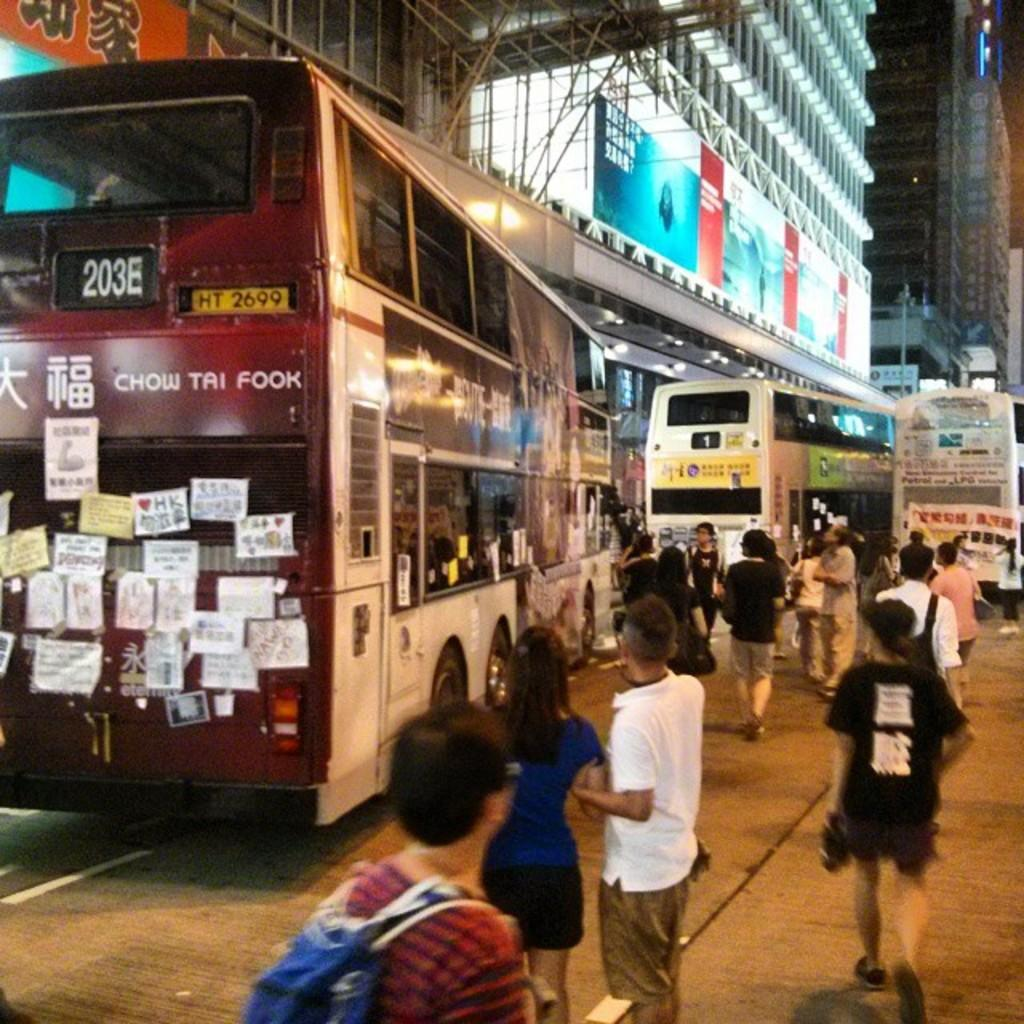<image>
Provide a brief description of the given image. Pedestrians are waiting as the Chow Tai Fook Bus drives by. 